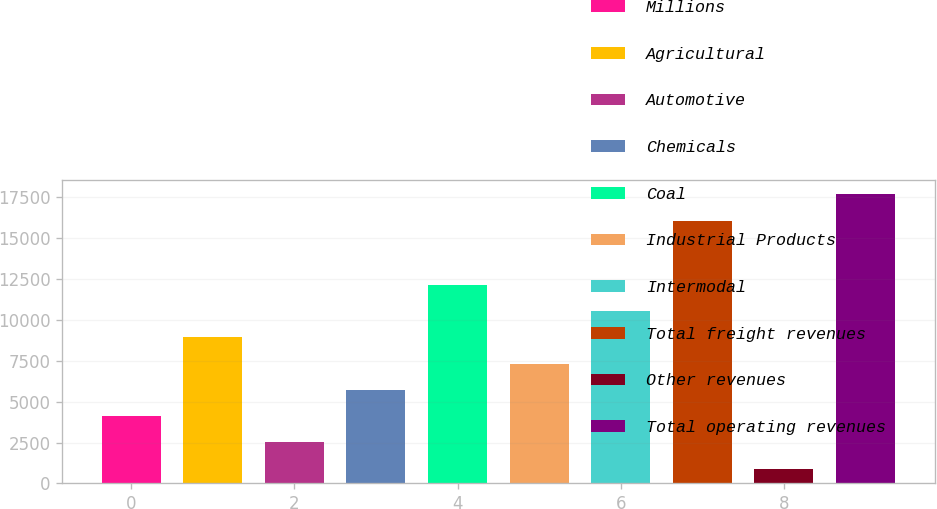Convert chart. <chart><loc_0><loc_0><loc_500><loc_500><bar_chart><fcel>Millions<fcel>Agricultural<fcel>Automotive<fcel>Chemicals<fcel>Coal<fcel>Industrial Products<fcel>Intermodal<fcel>Total freight revenues<fcel>Other revenues<fcel>Total operating revenues<nl><fcel>4109.8<fcel>8930.5<fcel>2502.9<fcel>5716.7<fcel>12144.3<fcel>7323.6<fcel>10537.4<fcel>16069<fcel>896<fcel>17675.9<nl></chart> 